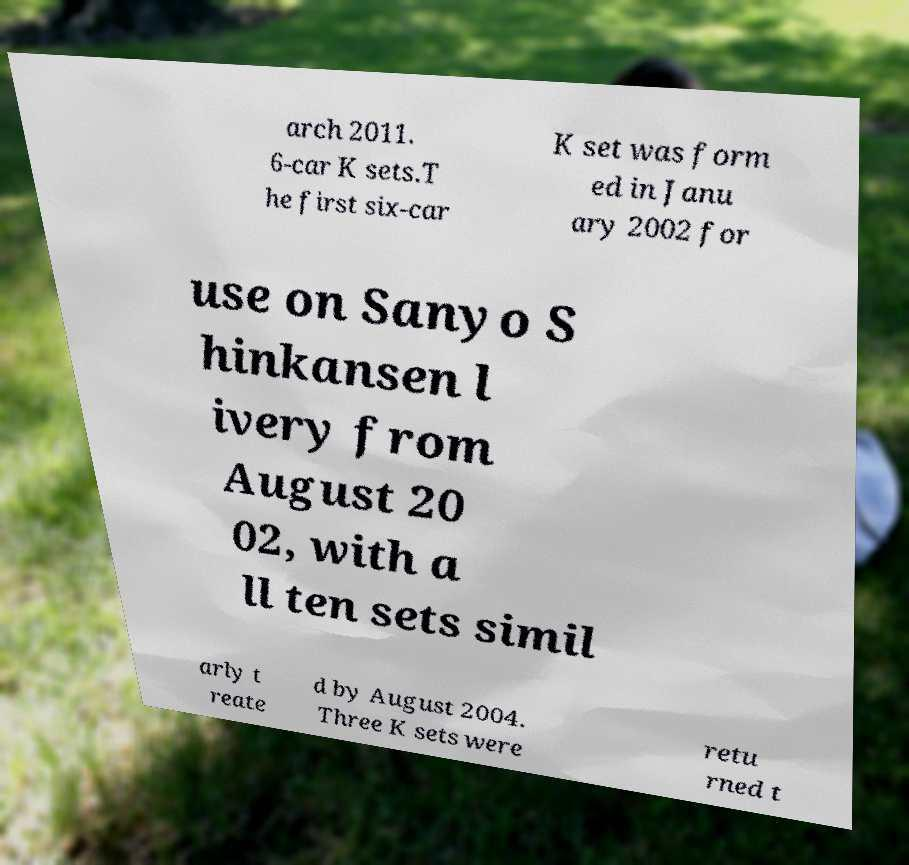There's text embedded in this image that I need extracted. Can you transcribe it verbatim? arch 2011. 6-car K sets.T he first six-car K set was form ed in Janu ary 2002 for use on Sanyo S hinkansen l ivery from August 20 02, with a ll ten sets simil arly t reate d by August 2004. Three K sets were retu rned t 